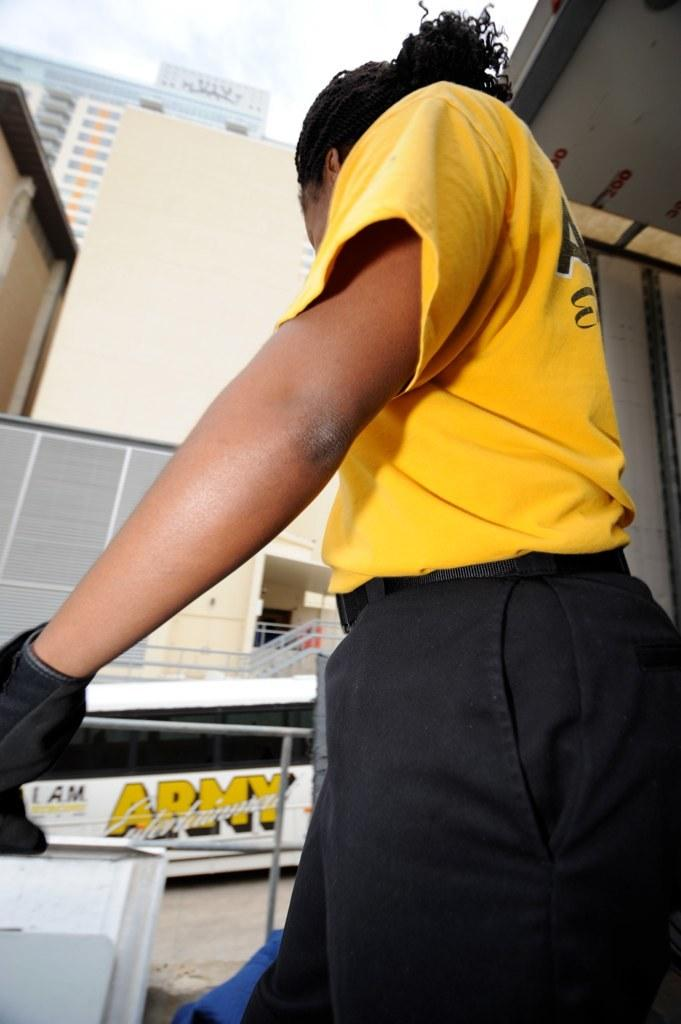Who or what is present in the image? There is a person in the image. What is the person standing near in the image? There is a fence in the image. What else can be seen on the ground in the image? There is a vehicle on the road in the image. What type of structures are visible in the background of the image? There are buildings in the image. What is visible above the structures and the person? The sky is visible in the image. What type of pet is the farmer holding in the image? There is no farmer or pet present in the image. 